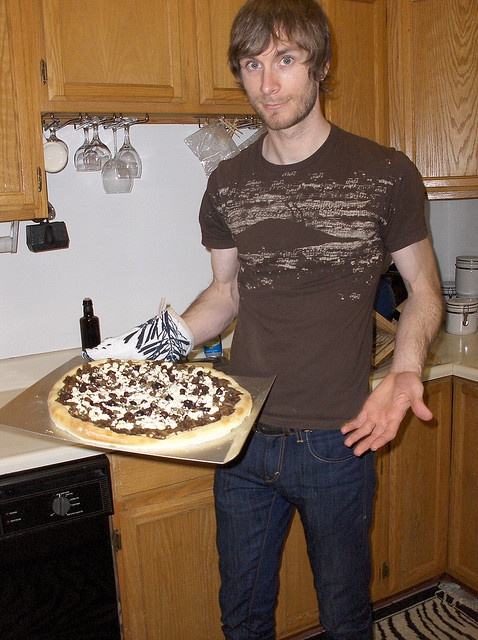Describe the objects in this image and their specific colors. I can see people in brown, black, maroon, and gray tones, oven in brown, black, lightgray, tan, and maroon tones, pizza in brown, ivory, tan, maroon, and gray tones, wine glass in brown, darkgray, lightgray, and gray tones, and cup in brown, darkgray, gray, and black tones in this image. 